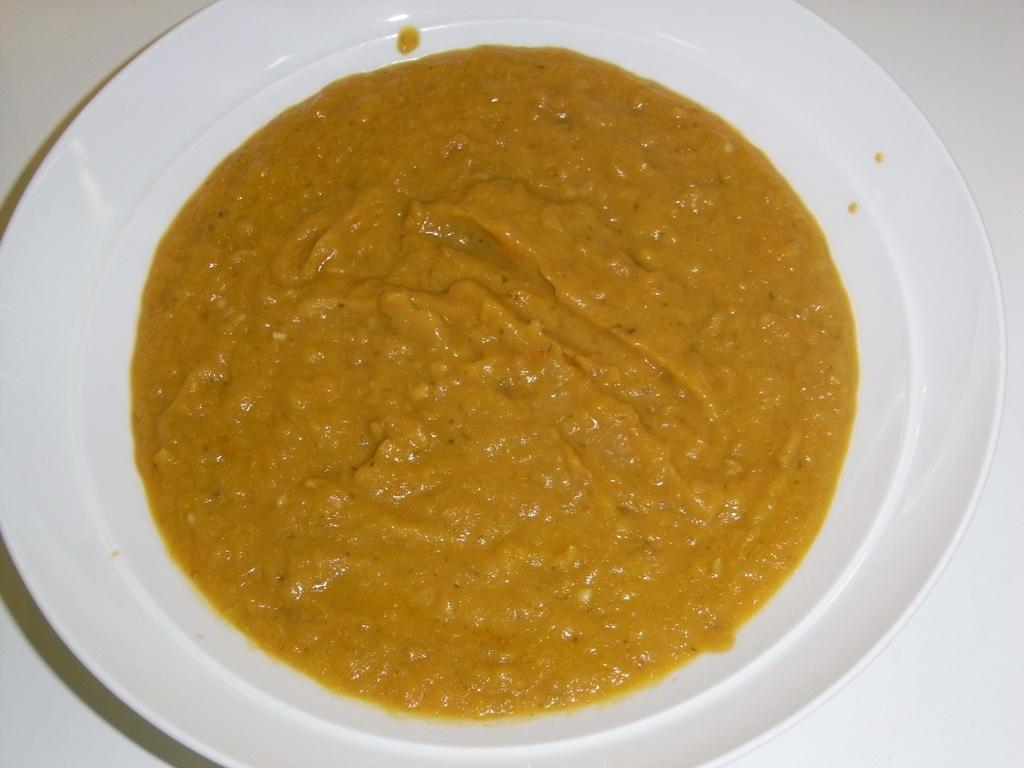What is present in the image related to food? There is food in the image. How is the food arranged or presented? The food is in a plate. What is the color of the platform the plate is on? The plate is on a white color platform. How many turkeys are visible in the image? There are no turkeys present in the image. What type of spoon is used to eat the food in the image? The image does not show any spoons, so it cannot be determined what type of spoon might be used to eat the food. 